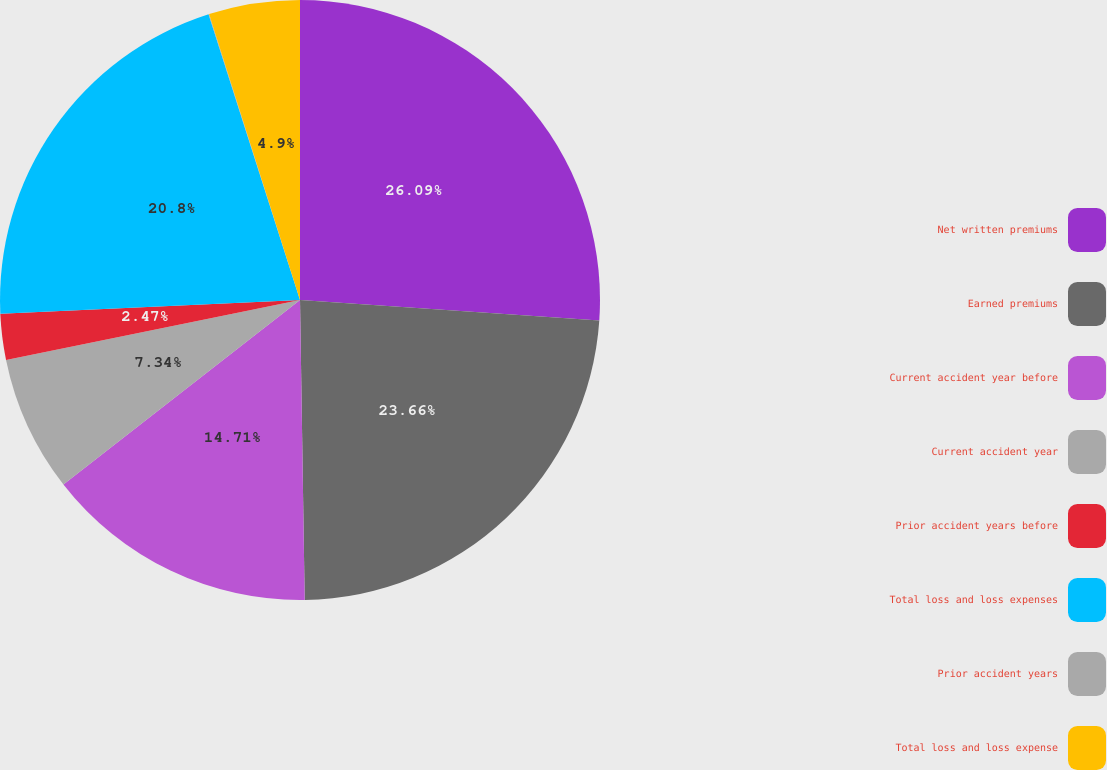Convert chart. <chart><loc_0><loc_0><loc_500><loc_500><pie_chart><fcel>Net written premiums<fcel>Earned premiums<fcel>Current accident year before<fcel>Current accident year<fcel>Prior accident years before<fcel>Total loss and loss expenses<fcel>Prior accident years<fcel>Total loss and loss expense<nl><fcel>26.09%<fcel>23.66%<fcel>14.71%<fcel>7.34%<fcel>2.47%<fcel>20.8%<fcel>0.03%<fcel>4.9%<nl></chart> 